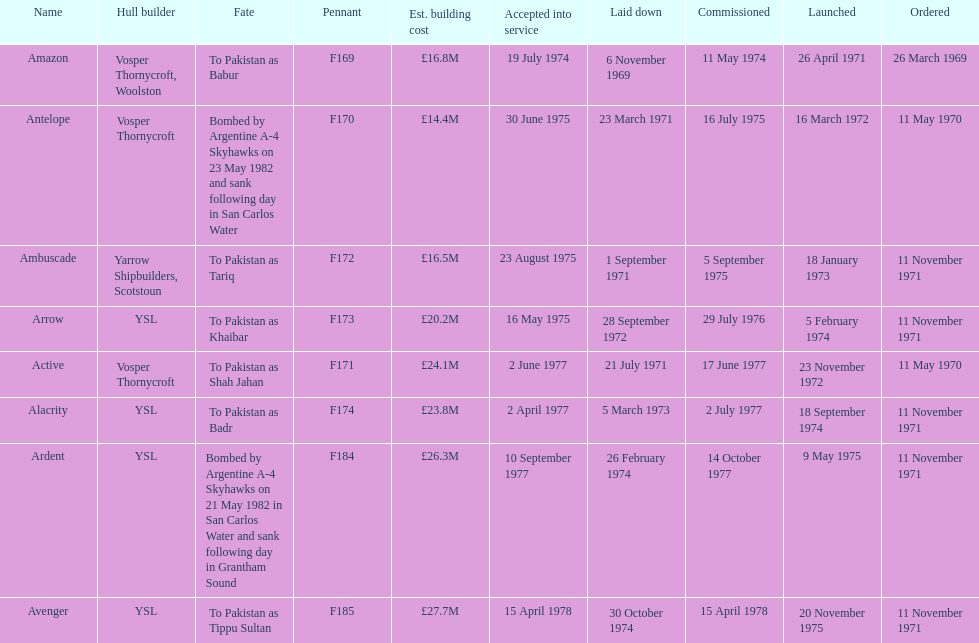How many ships were laid down in september? 2. Write the full table. {'header': ['Name', 'Hull builder', 'Fate', 'Pennant', 'Est. building cost', 'Accepted into service', 'Laid down', 'Commissioned', 'Launched', 'Ordered'], 'rows': [['Amazon', 'Vosper Thornycroft, Woolston', 'To Pakistan as Babur', 'F169', '£16.8M', '19 July 1974', '6 November 1969', '11 May 1974', '26 April 1971', '26 March 1969'], ['Antelope', 'Vosper Thornycroft', 'Bombed by Argentine A-4 Skyhawks on 23 May 1982 and sank following day in San Carlos Water', 'F170', '£14.4M', '30 June 1975', '23 March 1971', '16 July 1975', '16 March 1972', '11 May 1970'], ['Ambuscade', 'Yarrow Shipbuilders, Scotstoun', 'To Pakistan as Tariq', 'F172', '£16.5M', '23 August 1975', '1 September 1971', '5 September 1975', '18 January 1973', '11 November 1971'], ['Arrow', 'YSL', 'To Pakistan as Khaibar', 'F173', '£20.2M', '16 May 1975', '28 September 1972', '29 July 1976', '5 February 1974', '11 November 1971'], ['Active', 'Vosper Thornycroft', 'To Pakistan as Shah Jahan', 'F171', '£24.1M', '2 June 1977', '21 July 1971', '17 June 1977', '23 November 1972', '11 May 1970'], ['Alacrity', 'YSL', 'To Pakistan as Badr', 'F174', '£23.8M', '2 April 1977', '5 March 1973', '2 July 1977', '18 September 1974', '11 November 1971'], ['Ardent', 'YSL', 'Bombed by Argentine A-4 Skyhawks on 21 May 1982 in San Carlos Water and sank following day in Grantham Sound', 'F184', '£26.3M', '10 September 1977', '26 February 1974', '14 October 1977', '9 May 1975', '11 November 1971'], ['Avenger', 'YSL', 'To Pakistan as Tippu Sultan', 'F185', '£27.7M', '15 April 1978', '30 October 1974', '15 April 1978', '20 November 1975', '11 November 1971']]} 